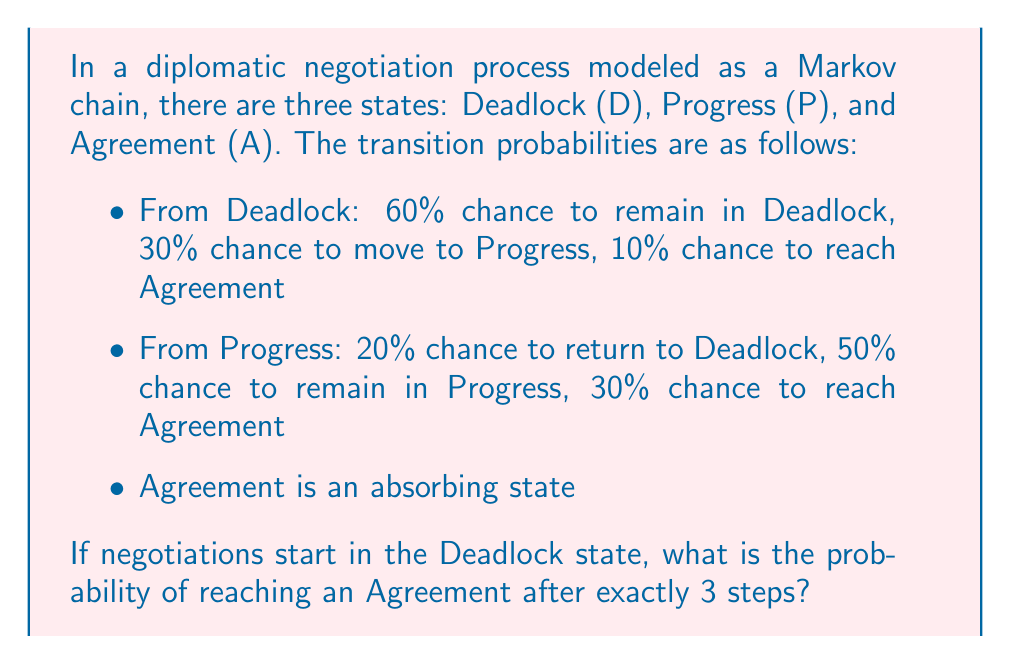Give your solution to this math problem. To solve this problem, we'll use the Markov chain transition matrix and calculate the probability of reaching the Agreement state after exactly 3 steps.

Step 1: Define the transition matrix P
$$P = \begin{bmatrix}
0.6 & 0.3 & 0.1 \\
0.2 & 0.5 & 0.3 \\
0 & 0 & 1
\end{bmatrix}$$

Step 2: Calculate $P^3$ (the transition matrix after 3 steps)
$$P^3 = P \times P \times P = \begin{bmatrix}
0.288 & 0.333 & 0.379 \\
0.172 & 0.398 & 0.430 \\
0 & 0 & 1
\end{bmatrix}$$

Step 3: Identify the probability of reaching Agreement (A) from Deadlock (D) after exactly 3 steps
This probability is found in the first row (representing the starting state of Deadlock), third column (representing the ending state of Agreement) of $P^3$.

The probability is 0.379 or 37.9%.
Answer: 0.379 